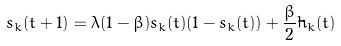<formula> <loc_0><loc_0><loc_500><loc_500>s _ { k } ( t + 1 ) = \lambda ( 1 - \beta ) s _ { k } ( t ) ( 1 - s _ { k } ( t ) ) + \frac { \beta } { 2 } \tilde { h } _ { k } ( t )</formula> 